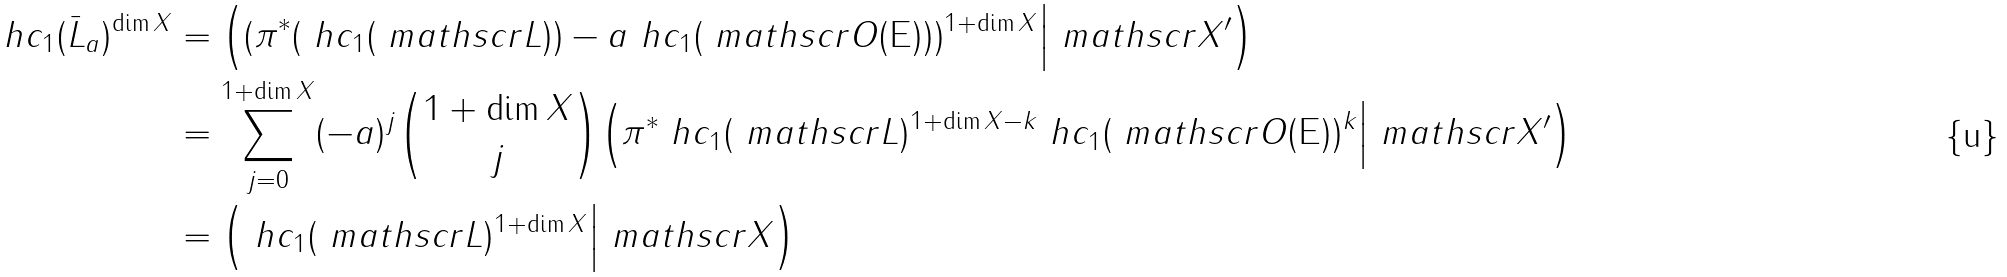<formula> <loc_0><loc_0><loc_500><loc_500>\ h c _ { 1 } ( \bar { L } _ { a } ) ^ { \dim X } & = \Big ( ( \pi ^ { * } ( \ h c _ { 1 } ( \ m a t h s c r L ) ) - a \ h c _ { 1 } ( \ m a t h s c r O ( \mathsf E ) ) ) ^ { 1 + \dim X } \Big | \ m a t h s c r X ^ { \prime } \Big ) \\ & = \sum _ { j = 0 } ^ { 1 + \dim X } ( - a ) ^ { j } \binom { 1 + \dim X } j \Big ( \pi ^ { * } \ h c _ { 1 } ( \ m a t h s c r L ) ^ { 1 + \dim X - k } \ h c _ { 1 } ( \ m a t h s c r O ( \mathsf E ) ) ^ { k } \Big | \ m a t h s c r X ^ { \prime } \Big ) \\ & = \Big ( \ h c _ { 1 } ( \ m a t h s c r L ) ^ { 1 + \dim X } \Big | \ m a t h s c r X \Big )</formula> 